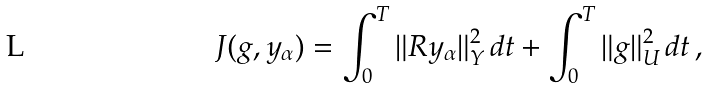<formula> <loc_0><loc_0><loc_500><loc_500>J ( g , y _ { \alpha } ) = \int _ { 0 } ^ { T } \| R y _ { \alpha } \| _ { Y } ^ { 2 } \, d t + \int _ { 0 } ^ { T } \| g \| ^ { 2 } _ { U } \, d t \, ,</formula> 